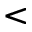Convert formula to latex. <formula><loc_0><loc_0><loc_500><loc_500><</formula> 